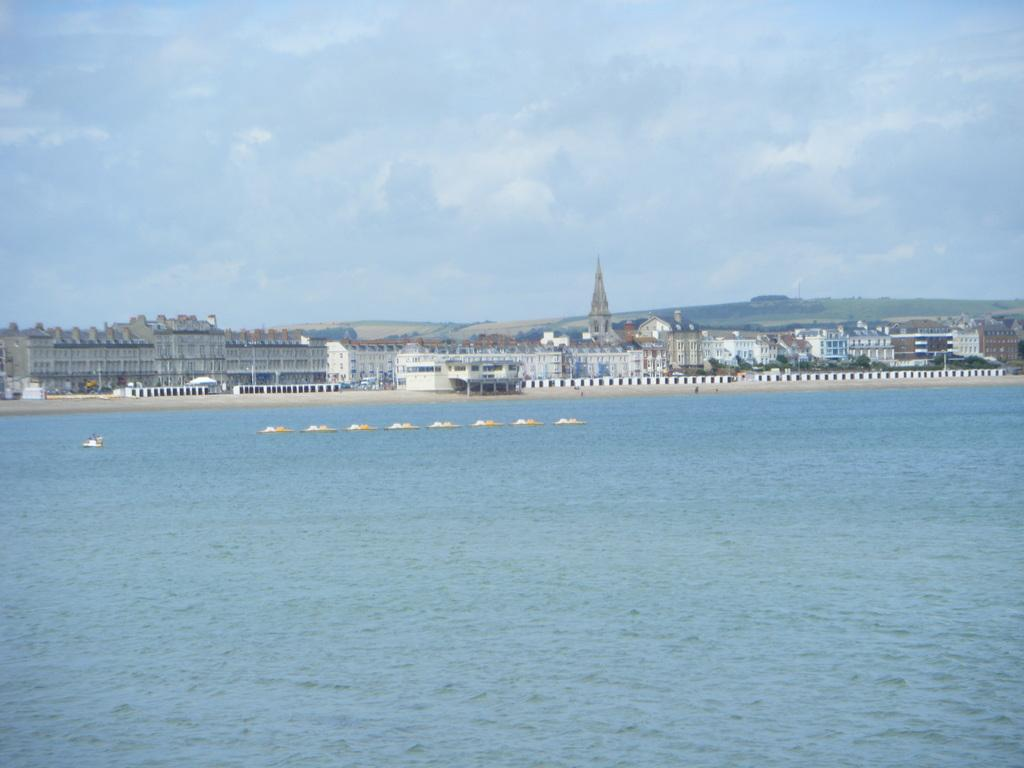What is the primary element visible in the image? There is water in the image. What can be seen floating on the water? There are white and yellow color things on the water. What type of structures can be seen in the distance? There are buildings in the background of the image. How would you describe the sky in the image? The sky is cloudy in the background of the image. Where is the toothpaste located in the image? There is no toothpaste present in the image. What type of dirt can be seen on the coast in the image? There is no coast or dirt present in the image. 